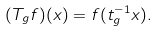Convert formula to latex. <formula><loc_0><loc_0><loc_500><loc_500>( T _ { g } f ) ( x ) = f ( t ^ { - 1 } _ { g } x ) .</formula> 